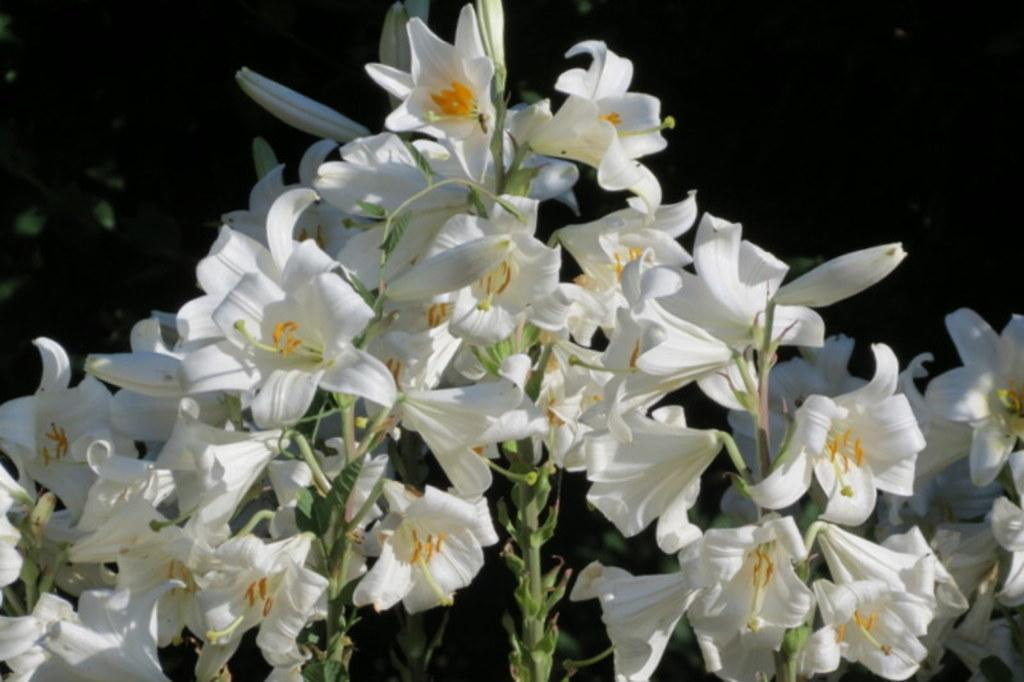What type of living organisms can be seen in the image? There are flowers and plants in the image. Can you describe the plants in the image? The plants in the image are not specified, but they are present alongside the flowers. What type of produce is being harvested from the bucket in the image? There is no bucket or produce present in the image; it only features flowers and plants. 